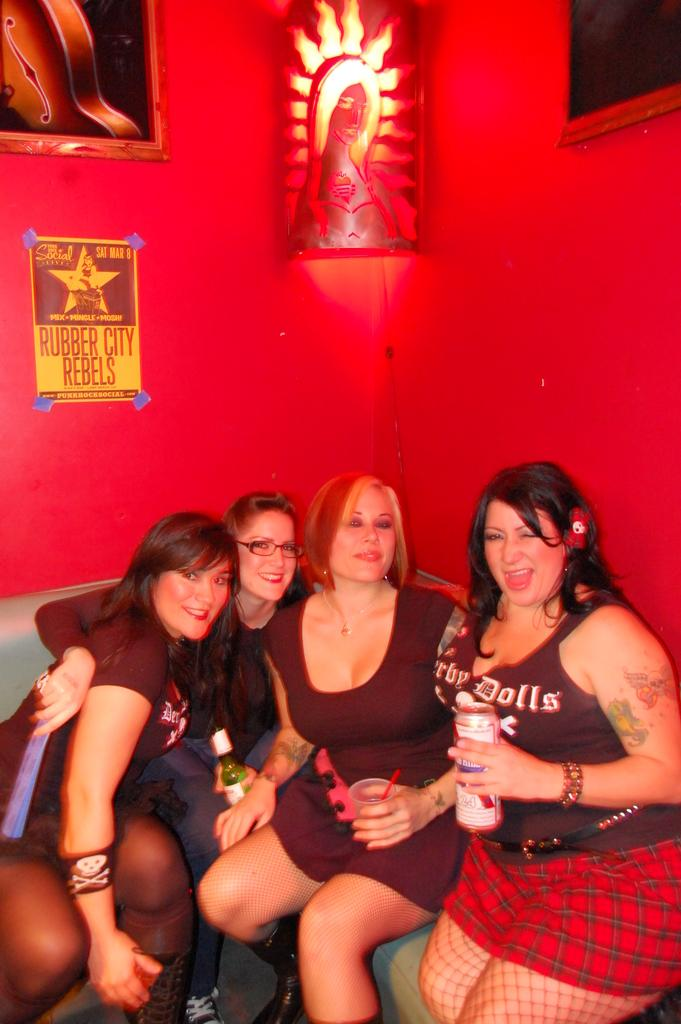What are the people in the image doing? The people in the image are sitting. Can you describe the lady's position in the image? The lady is sitting on the right side of the image. What is the lady holding in the image? The lady is holding a tin. What can be seen in the background of the image? There is a wall in the background of the image, and frames are placed on the wall. Is there a rainstorm happening in the image? No, there is no rainstorm depicted in the image. Can you see a dock in the image? No, there is no dock present in the image. 